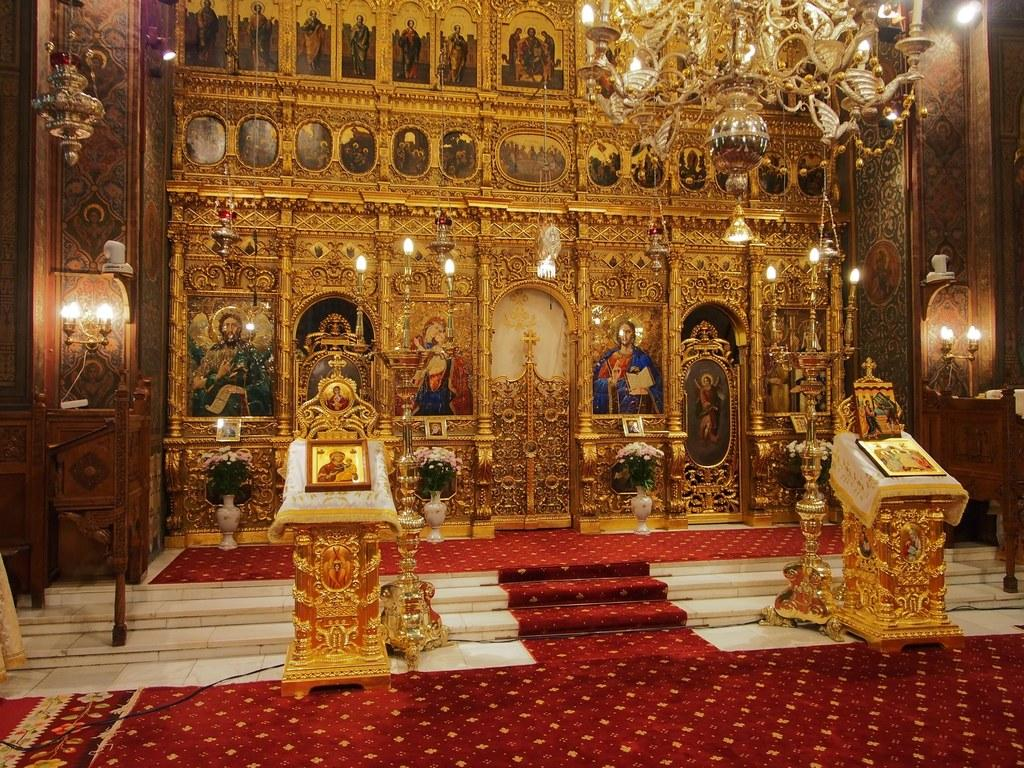What type of location is depicted in the image? The image shows an inner view of a building. What is on the floor in the image? There is a carpet, photos, and flower pots on the floor. What type of lighting is present in the image? There is a chandelier light and lights around the room. How many different types of lighting can be seen in the image? There are two types of lighting: a chandelier light and lights around the room. How many cows can be seen grazing on the street in the image? There are no cows or streets present in the image; it shows an inner view of a building with a carpet, photos, flower pots, a chandelier light, and lights around the room. 